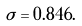<formula> <loc_0><loc_0><loc_500><loc_500>\sigma = 0 . 8 4 6 .</formula> 